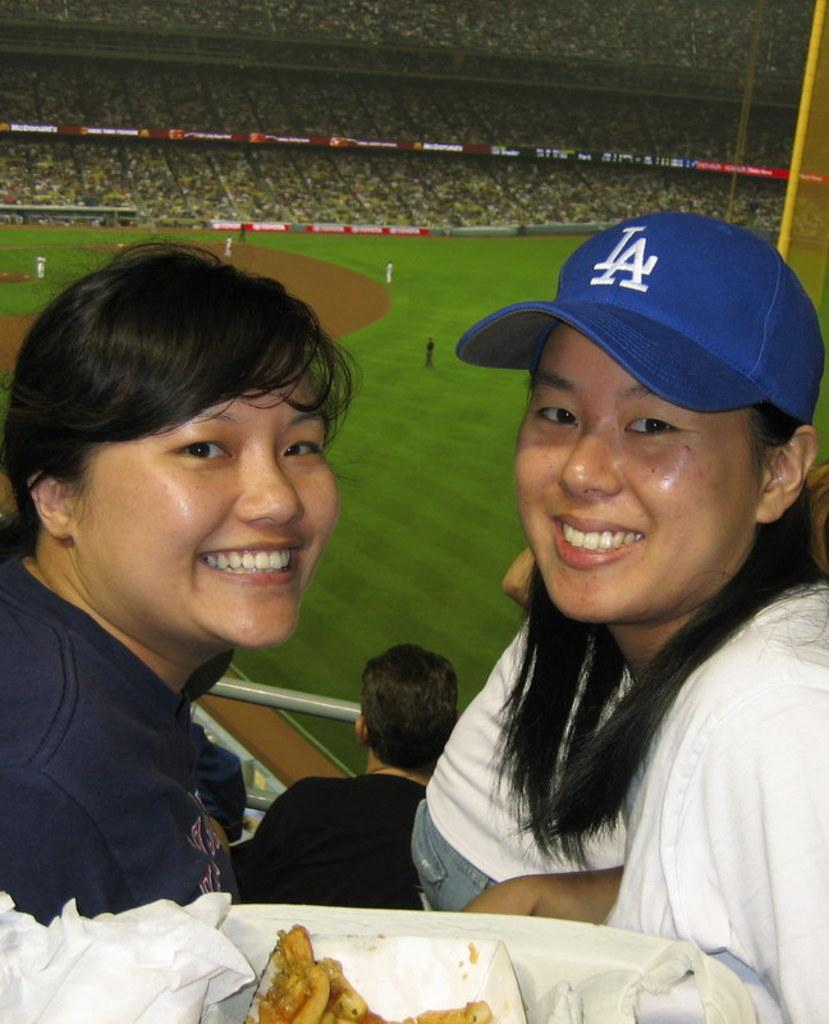How many girls are in the image? There are two girls in the image. Where are the girls located in the image? The girls are sitting in the front. What expression do the girls have in the image? The girls are smiling. What are the girls doing in the image? The girls are giving a pose to the camera. What can be seen in the background of the image? There is a cricket stadium in the background of the image. How many audience members are visible in the stadium? There are many audience members sitting on chairs in the stadium. Can you see a kitty playing with a vein in the image? There is no kitty or vein present in the image. 